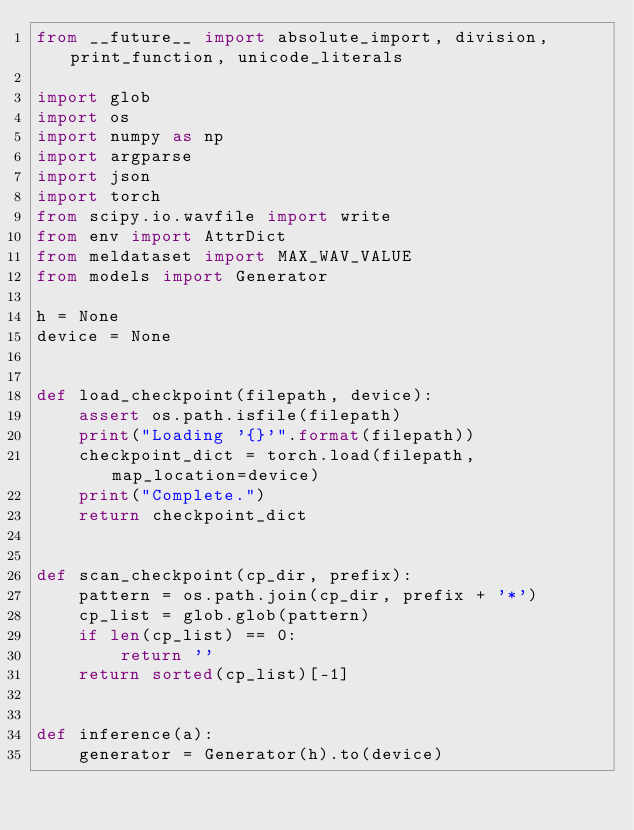Convert code to text. <code><loc_0><loc_0><loc_500><loc_500><_Python_>from __future__ import absolute_import, division, print_function, unicode_literals

import glob
import os
import numpy as np
import argparse
import json
import torch
from scipy.io.wavfile import write
from env import AttrDict
from meldataset import MAX_WAV_VALUE
from models import Generator

h = None
device = None


def load_checkpoint(filepath, device):
    assert os.path.isfile(filepath)
    print("Loading '{}'".format(filepath))
    checkpoint_dict = torch.load(filepath, map_location=device)
    print("Complete.")
    return checkpoint_dict


def scan_checkpoint(cp_dir, prefix):
    pattern = os.path.join(cp_dir, prefix + '*')
    cp_list = glob.glob(pattern)
    if len(cp_list) == 0:
        return ''
    return sorted(cp_list)[-1]


def inference(a):
    generator = Generator(h).to(device)
</code> 